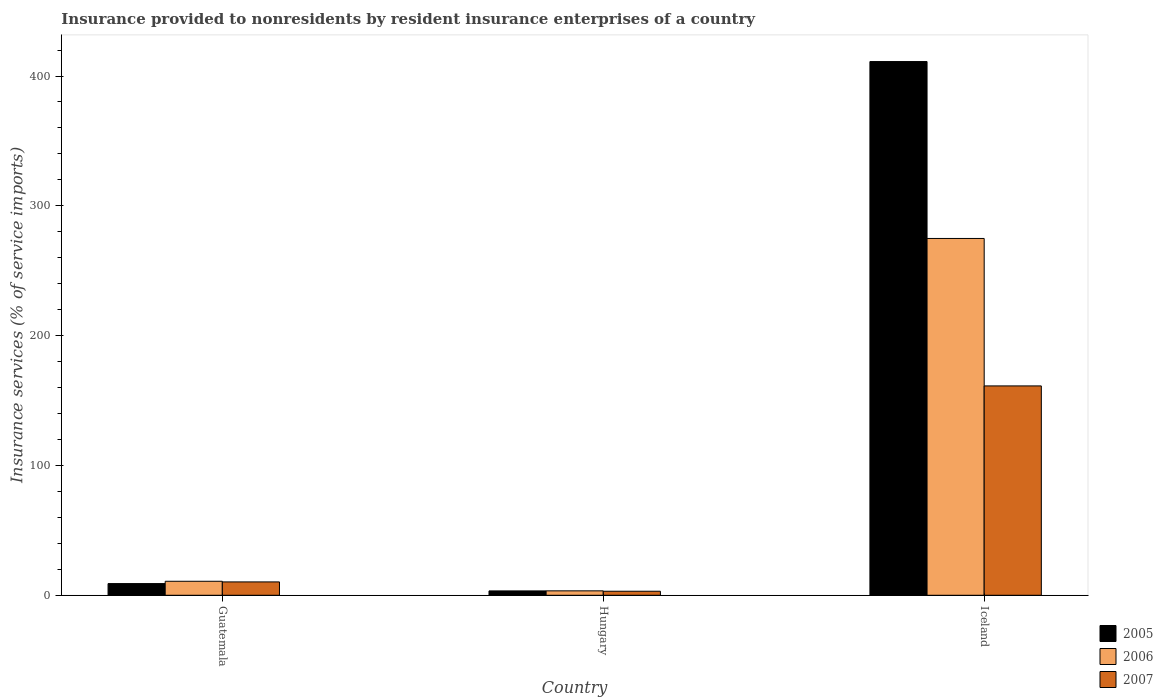How many groups of bars are there?
Your response must be concise. 3. Are the number of bars per tick equal to the number of legend labels?
Provide a succinct answer. Yes. What is the label of the 2nd group of bars from the left?
Your answer should be very brief. Hungary. In how many cases, is the number of bars for a given country not equal to the number of legend labels?
Ensure brevity in your answer.  0. What is the insurance provided to nonresidents in 2007 in Hungary?
Your response must be concise. 3.11. Across all countries, what is the maximum insurance provided to nonresidents in 2005?
Provide a short and direct response. 411.14. Across all countries, what is the minimum insurance provided to nonresidents in 2007?
Provide a short and direct response. 3.11. In which country was the insurance provided to nonresidents in 2007 minimum?
Provide a short and direct response. Hungary. What is the total insurance provided to nonresidents in 2006 in the graph?
Provide a short and direct response. 289.05. What is the difference between the insurance provided to nonresidents in 2005 in Hungary and that in Iceland?
Keep it short and to the point. -407.77. What is the difference between the insurance provided to nonresidents in 2007 in Hungary and the insurance provided to nonresidents in 2005 in Iceland?
Your answer should be compact. -408.02. What is the average insurance provided to nonresidents in 2006 per country?
Ensure brevity in your answer.  96.35. What is the difference between the insurance provided to nonresidents of/in 2007 and insurance provided to nonresidents of/in 2005 in Iceland?
Make the answer very short. -249.86. In how many countries, is the insurance provided to nonresidents in 2006 greater than 120 %?
Ensure brevity in your answer.  1. What is the ratio of the insurance provided to nonresidents in 2005 in Guatemala to that in Iceland?
Provide a succinct answer. 0.02. What is the difference between the highest and the second highest insurance provided to nonresidents in 2005?
Your answer should be very brief. -5.65. What is the difference between the highest and the lowest insurance provided to nonresidents in 2006?
Ensure brevity in your answer.  271.46. Does the graph contain any zero values?
Your answer should be compact. No. Where does the legend appear in the graph?
Offer a terse response. Bottom right. How are the legend labels stacked?
Provide a short and direct response. Vertical. What is the title of the graph?
Your answer should be very brief. Insurance provided to nonresidents by resident insurance enterprises of a country. Does "2009" appear as one of the legend labels in the graph?
Ensure brevity in your answer.  No. What is the label or title of the X-axis?
Offer a very short reply. Country. What is the label or title of the Y-axis?
Offer a terse response. Insurance services (% of service imports). What is the Insurance services (% of service imports) in 2005 in Guatemala?
Make the answer very short. 9.01. What is the Insurance services (% of service imports) of 2006 in Guatemala?
Make the answer very short. 10.78. What is the Insurance services (% of service imports) in 2007 in Guatemala?
Offer a terse response. 10.29. What is the Insurance services (% of service imports) of 2005 in Hungary?
Provide a succinct answer. 3.36. What is the Insurance services (% of service imports) in 2006 in Hungary?
Your response must be concise. 3.4. What is the Insurance services (% of service imports) of 2007 in Hungary?
Offer a terse response. 3.11. What is the Insurance services (% of service imports) in 2005 in Iceland?
Your response must be concise. 411.14. What is the Insurance services (% of service imports) in 2006 in Iceland?
Your response must be concise. 274.86. What is the Insurance services (% of service imports) of 2007 in Iceland?
Provide a succinct answer. 161.27. Across all countries, what is the maximum Insurance services (% of service imports) in 2005?
Offer a very short reply. 411.14. Across all countries, what is the maximum Insurance services (% of service imports) in 2006?
Offer a terse response. 274.86. Across all countries, what is the maximum Insurance services (% of service imports) in 2007?
Your response must be concise. 161.27. Across all countries, what is the minimum Insurance services (% of service imports) of 2005?
Keep it short and to the point. 3.36. Across all countries, what is the minimum Insurance services (% of service imports) of 2006?
Give a very brief answer. 3.4. Across all countries, what is the minimum Insurance services (% of service imports) in 2007?
Make the answer very short. 3.11. What is the total Insurance services (% of service imports) of 2005 in the graph?
Provide a short and direct response. 423.51. What is the total Insurance services (% of service imports) in 2006 in the graph?
Keep it short and to the point. 289.05. What is the total Insurance services (% of service imports) in 2007 in the graph?
Provide a succinct answer. 174.67. What is the difference between the Insurance services (% of service imports) in 2005 in Guatemala and that in Hungary?
Your answer should be compact. 5.65. What is the difference between the Insurance services (% of service imports) in 2006 in Guatemala and that in Hungary?
Make the answer very short. 7.38. What is the difference between the Insurance services (% of service imports) of 2007 in Guatemala and that in Hungary?
Your answer should be very brief. 7.18. What is the difference between the Insurance services (% of service imports) in 2005 in Guatemala and that in Iceland?
Your response must be concise. -402.13. What is the difference between the Insurance services (% of service imports) of 2006 in Guatemala and that in Iceland?
Offer a terse response. -264.08. What is the difference between the Insurance services (% of service imports) in 2007 in Guatemala and that in Iceland?
Make the answer very short. -150.99. What is the difference between the Insurance services (% of service imports) in 2005 in Hungary and that in Iceland?
Keep it short and to the point. -407.77. What is the difference between the Insurance services (% of service imports) of 2006 in Hungary and that in Iceland?
Provide a succinct answer. -271.46. What is the difference between the Insurance services (% of service imports) in 2007 in Hungary and that in Iceland?
Provide a succinct answer. -158.16. What is the difference between the Insurance services (% of service imports) of 2005 in Guatemala and the Insurance services (% of service imports) of 2006 in Hungary?
Give a very brief answer. 5.6. What is the difference between the Insurance services (% of service imports) of 2005 in Guatemala and the Insurance services (% of service imports) of 2007 in Hungary?
Offer a terse response. 5.9. What is the difference between the Insurance services (% of service imports) in 2006 in Guatemala and the Insurance services (% of service imports) in 2007 in Hungary?
Provide a succinct answer. 7.67. What is the difference between the Insurance services (% of service imports) of 2005 in Guatemala and the Insurance services (% of service imports) of 2006 in Iceland?
Keep it short and to the point. -265.85. What is the difference between the Insurance services (% of service imports) of 2005 in Guatemala and the Insurance services (% of service imports) of 2007 in Iceland?
Give a very brief answer. -152.26. What is the difference between the Insurance services (% of service imports) of 2006 in Guatemala and the Insurance services (% of service imports) of 2007 in Iceland?
Keep it short and to the point. -150.49. What is the difference between the Insurance services (% of service imports) in 2005 in Hungary and the Insurance services (% of service imports) in 2006 in Iceland?
Offer a terse response. -271.5. What is the difference between the Insurance services (% of service imports) in 2005 in Hungary and the Insurance services (% of service imports) in 2007 in Iceland?
Your response must be concise. -157.91. What is the difference between the Insurance services (% of service imports) of 2006 in Hungary and the Insurance services (% of service imports) of 2007 in Iceland?
Provide a succinct answer. -157.87. What is the average Insurance services (% of service imports) of 2005 per country?
Ensure brevity in your answer.  141.17. What is the average Insurance services (% of service imports) of 2006 per country?
Ensure brevity in your answer.  96.35. What is the average Insurance services (% of service imports) in 2007 per country?
Provide a short and direct response. 58.22. What is the difference between the Insurance services (% of service imports) of 2005 and Insurance services (% of service imports) of 2006 in Guatemala?
Provide a short and direct response. -1.78. What is the difference between the Insurance services (% of service imports) in 2005 and Insurance services (% of service imports) in 2007 in Guatemala?
Provide a succinct answer. -1.28. What is the difference between the Insurance services (% of service imports) in 2006 and Insurance services (% of service imports) in 2007 in Guatemala?
Offer a very short reply. 0.5. What is the difference between the Insurance services (% of service imports) of 2005 and Insurance services (% of service imports) of 2006 in Hungary?
Your response must be concise. -0.04. What is the difference between the Insurance services (% of service imports) of 2005 and Insurance services (% of service imports) of 2007 in Hungary?
Your answer should be compact. 0.25. What is the difference between the Insurance services (% of service imports) in 2006 and Insurance services (% of service imports) in 2007 in Hungary?
Your response must be concise. 0.29. What is the difference between the Insurance services (% of service imports) of 2005 and Insurance services (% of service imports) of 2006 in Iceland?
Provide a succinct answer. 136.27. What is the difference between the Insurance services (% of service imports) in 2005 and Insurance services (% of service imports) in 2007 in Iceland?
Keep it short and to the point. 249.86. What is the difference between the Insurance services (% of service imports) of 2006 and Insurance services (% of service imports) of 2007 in Iceland?
Ensure brevity in your answer.  113.59. What is the ratio of the Insurance services (% of service imports) in 2005 in Guatemala to that in Hungary?
Keep it short and to the point. 2.68. What is the ratio of the Insurance services (% of service imports) in 2006 in Guatemala to that in Hungary?
Your answer should be compact. 3.17. What is the ratio of the Insurance services (% of service imports) in 2007 in Guatemala to that in Hungary?
Make the answer very short. 3.31. What is the ratio of the Insurance services (% of service imports) of 2005 in Guatemala to that in Iceland?
Your answer should be compact. 0.02. What is the ratio of the Insurance services (% of service imports) in 2006 in Guatemala to that in Iceland?
Provide a short and direct response. 0.04. What is the ratio of the Insurance services (% of service imports) of 2007 in Guatemala to that in Iceland?
Your answer should be compact. 0.06. What is the ratio of the Insurance services (% of service imports) of 2005 in Hungary to that in Iceland?
Your response must be concise. 0.01. What is the ratio of the Insurance services (% of service imports) in 2006 in Hungary to that in Iceland?
Your answer should be very brief. 0.01. What is the ratio of the Insurance services (% of service imports) of 2007 in Hungary to that in Iceland?
Your answer should be compact. 0.02. What is the difference between the highest and the second highest Insurance services (% of service imports) in 2005?
Your response must be concise. 402.13. What is the difference between the highest and the second highest Insurance services (% of service imports) of 2006?
Give a very brief answer. 264.08. What is the difference between the highest and the second highest Insurance services (% of service imports) of 2007?
Offer a very short reply. 150.99. What is the difference between the highest and the lowest Insurance services (% of service imports) of 2005?
Your answer should be very brief. 407.77. What is the difference between the highest and the lowest Insurance services (% of service imports) in 2006?
Your response must be concise. 271.46. What is the difference between the highest and the lowest Insurance services (% of service imports) in 2007?
Keep it short and to the point. 158.16. 